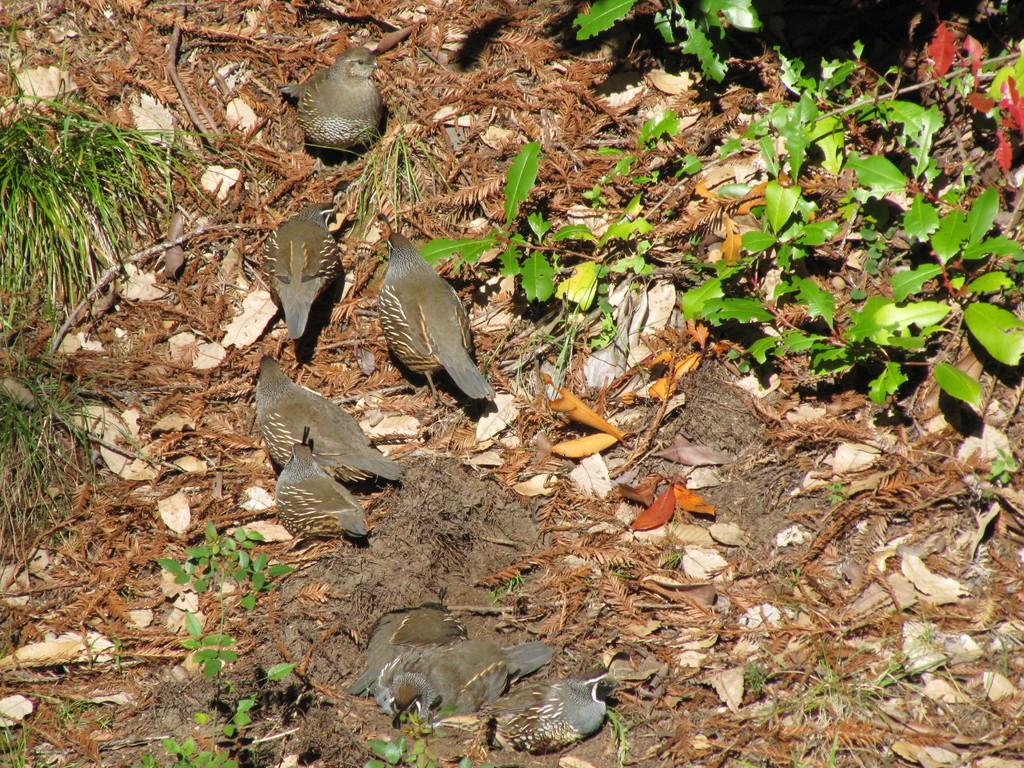What is located in the center of the image? There are birds in the center of the image. What can be seen on the ground in the image? There are dry leaves on the ground in the image. What type of vegetation is present in the image? There are plants in the image. What type of education is being offered in the room depicted in the image? There is no room or any indication of education in the image; it features birds and plants. 